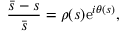<formula> <loc_0><loc_0><loc_500><loc_500>\frac { \bar { s } - s } { \bar { s } } = \rho ( s ) e ^ { i \theta ( s ) } ,</formula> 